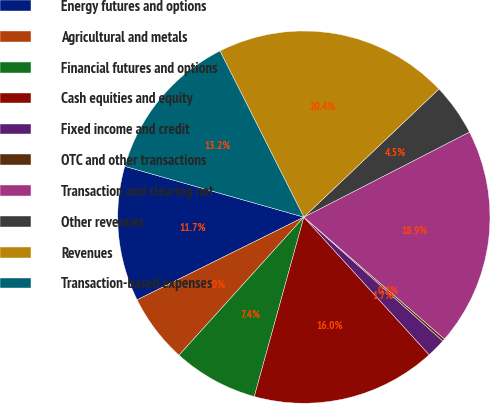Convert chart. <chart><loc_0><loc_0><loc_500><loc_500><pie_chart><fcel>Energy futures and options<fcel>Agricultural and metals<fcel>Financial futures and options<fcel>Cash equities and equity<fcel>Fixed income and credit<fcel>OTC and other transactions<fcel>Transaction and clearing net<fcel>Other revenues<fcel>Revenues<fcel>Transaction-based expenses<nl><fcel>11.73%<fcel>5.97%<fcel>7.41%<fcel>16.04%<fcel>1.66%<fcel>0.22%<fcel>18.92%<fcel>4.53%<fcel>20.36%<fcel>13.16%<nl></chart> 